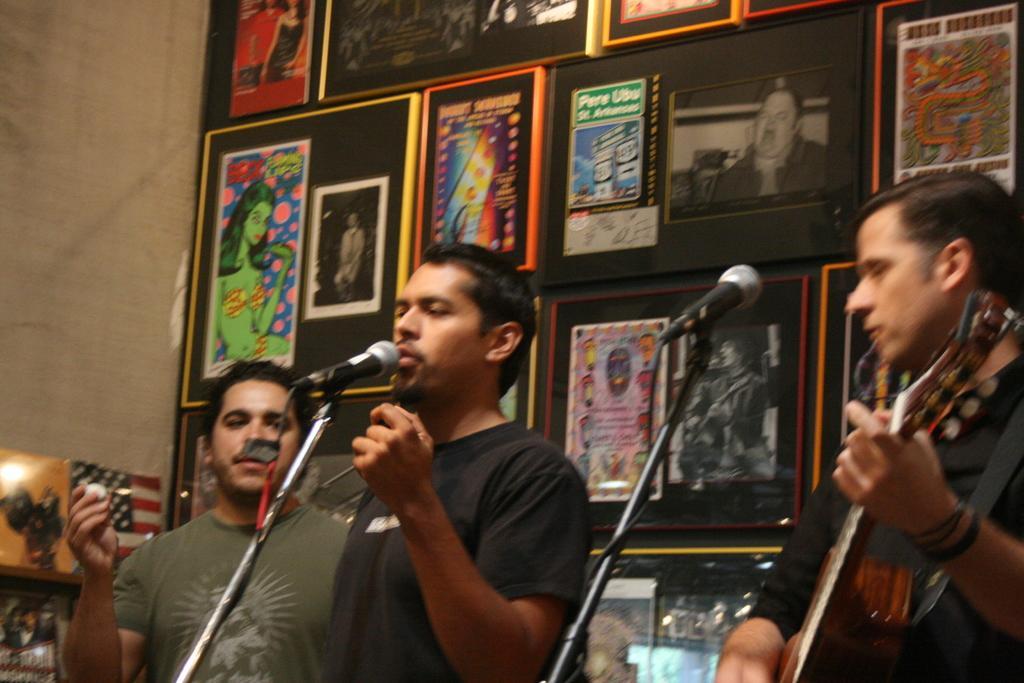Can you describe this image briefly? In this image we can see three person's, a person is holding an object and a person is playing a guitar, there are two mics in front of them and behind them there is a wall with picture frames and on the left side there is a flag and a picture frame on the shelf. 